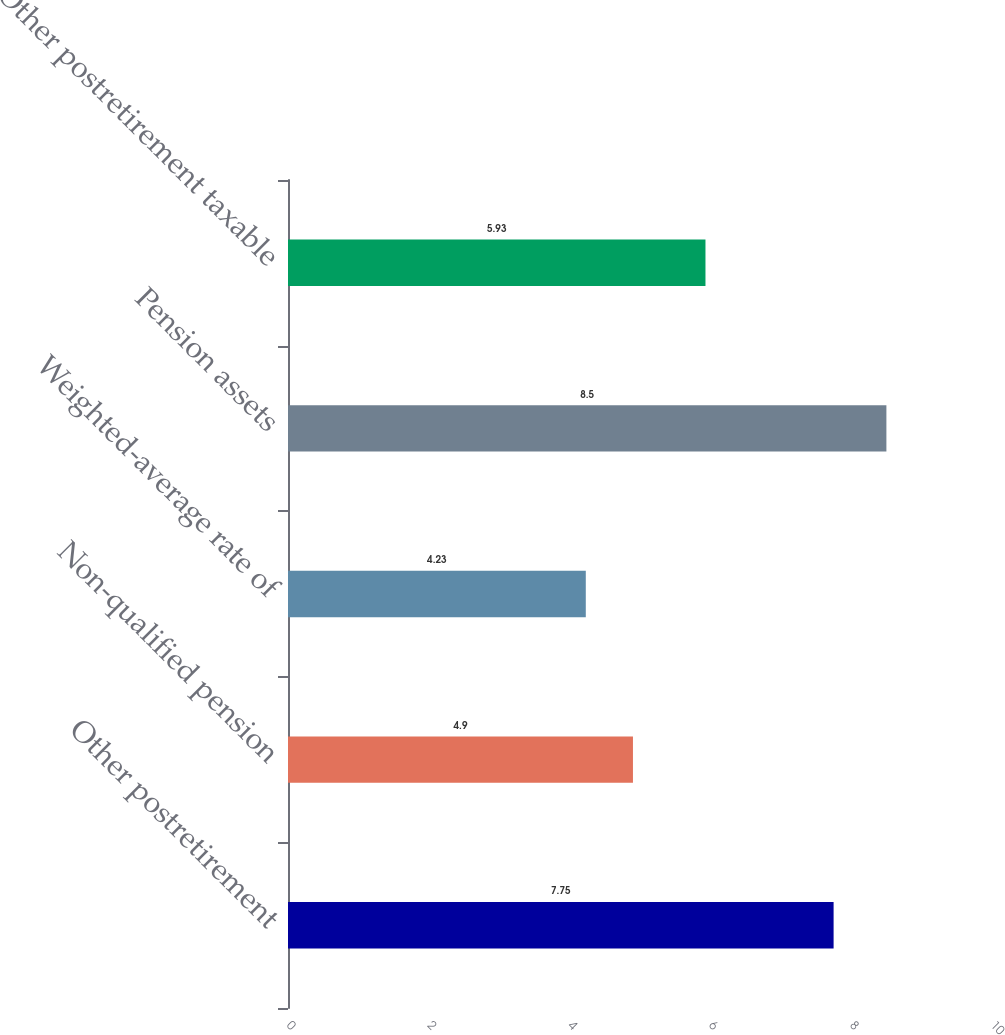<chart> <loc_0><loc_0><loc_500><loc_500><bar_chart><fcel>Other postretirement<fcel>Non-qualified pension<fcel>Weighted-average rate of<fcel>Pension assets<fcel>Other postretirement taxable<nl><fcel>7.75<fcel>4.9<fcel>4.23<fcel>8.5<fcel>5.93<nl></chart> 